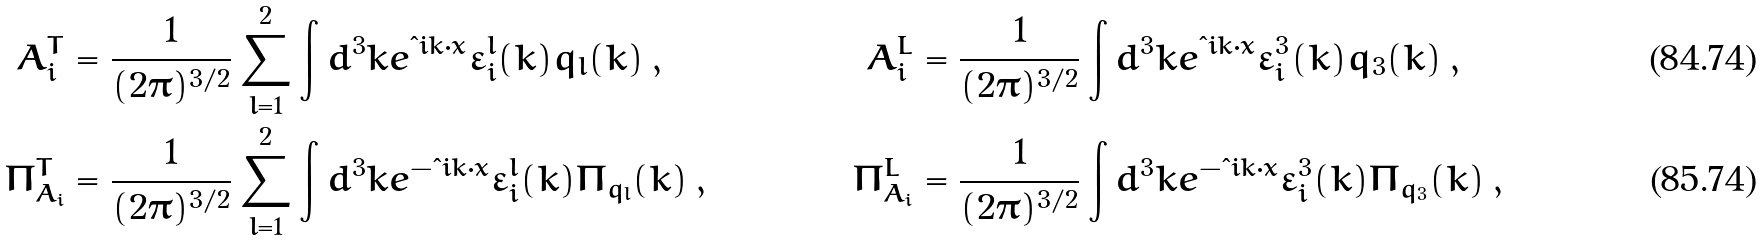<formula> <loc_0><loc_0><loc_500><loc_500>A ^ { T } _ { i } & = \frac { 1 } { ( 2 \pi ) ^ { 3 / 2 } } \sum ^ { 2 } _ { l = 1 } \int d ^ { 3 } k e ^ { \i i { k } \cdot { x } } \varepsilon ^ { l } _ { i } ( { k } ) q _ { l } ( { k } ) \, , & A ^ { L } _ { i } & = \frac { 1 } { ( 2 \pi ) ^ { 3 / 2 } } \int d ^ { 3 } k e ^ { \i i { k } \cdot { x } } \varepsilon ^ { 3 } _ { i } ( { k } ) q _ { 3 } ( { k } ) \, , \\ \Pi ^ { T } _ { A _ { i } } & = \frac { 1 } { ( 2 \pi ) ^ { 3 / 2 } } \sum ^ { 2 } _ { l = 1 } \int d ^ { 3 } k e ^ { - \i i { k } \cdot { x } } \varepsilon ^ { l } _ { i } ( { k } ) \Pi _ { q _ { l } } ( { k } ) \, , & \Pi ^ { L } _ { A _ { i } } & = \frac { 1 } { ( 2 \pi ) ^ { 3 / 2 } } \int d ^ { 3 } k e ^ { - \i i { k } \cdot { x } } \varepsilon ^ { 3 } _ { i } ( { k } ) \Pi _ { q _ { 3 } } ( { k } ) \, ,</formula> 